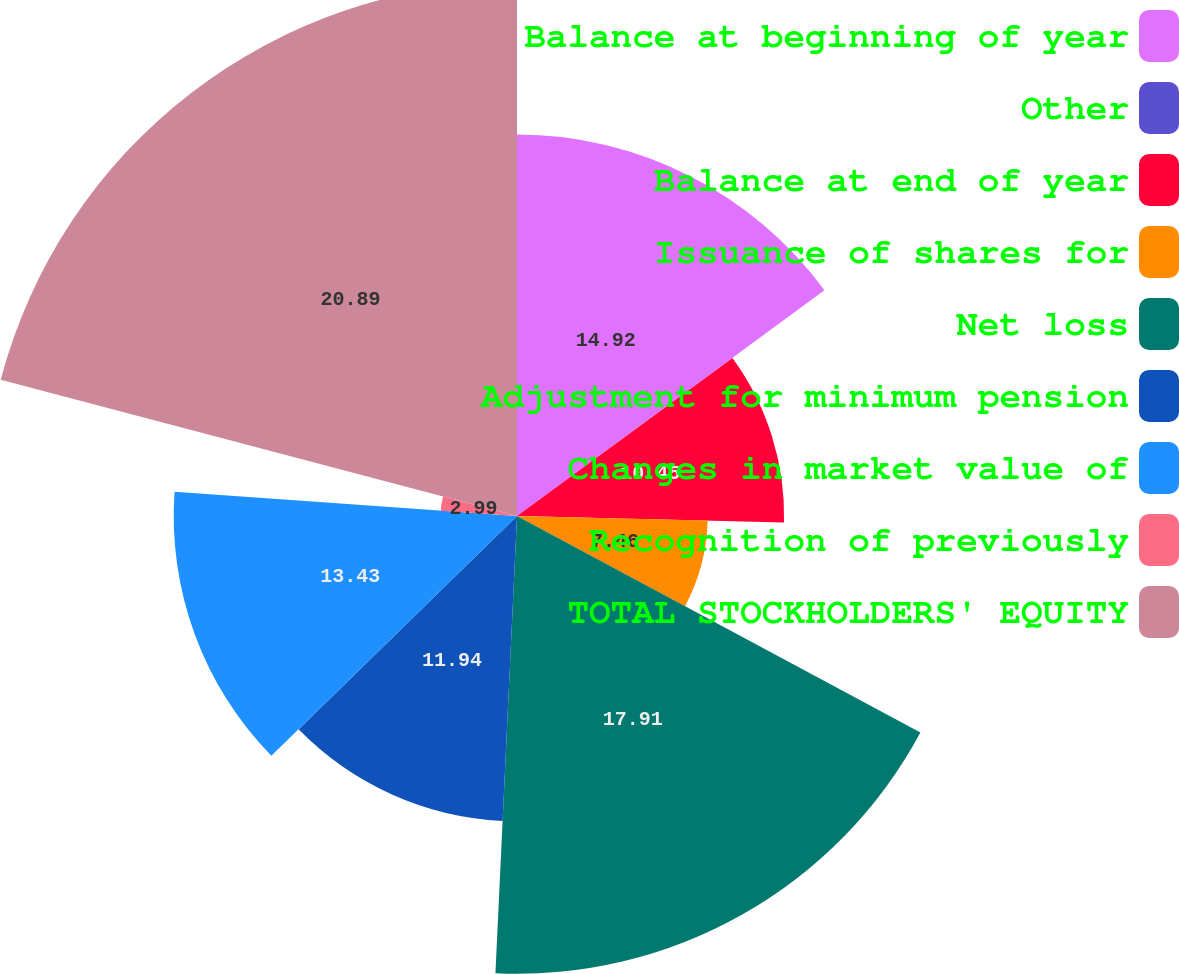<chart> <loc_0><loc_0><loc_500><loc_500><pie_chart><fcel>Balance at beginning of year<fcel>Other<fcel>Balance at end of year<fcel>Issuance of shares for<fcel>Net loss<fcel>Adjustment for minimum pension<fcel>Changes in market value of<fcel>Recognition of previously<fcel>TOTAL STOCKHOLDERS' EQUITY<nl><fcel>14.92%<fcel>0.01%<fcel>10.45%<fcel>7.46%<fcel>17.91%<fcel>11.94%<fcel>13.43%<fcel>2.99%<fcel>20.89%<nl></chart> 